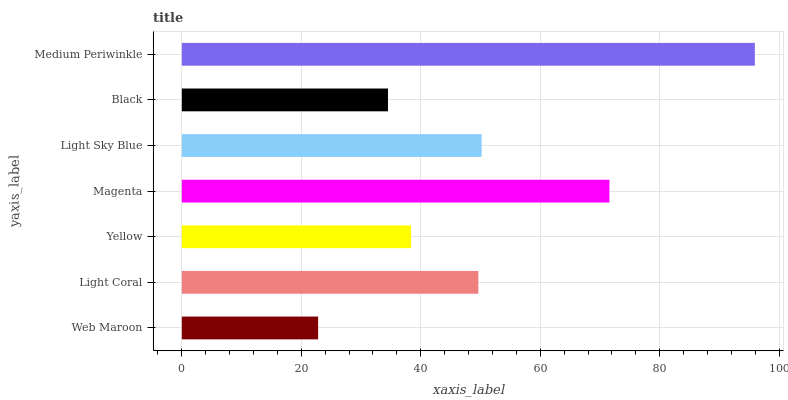Is Web Maroon the minimum?
Answer yes or no. Yes. Is Medium Periwinkle the maximum?
Answer yes or no. Yes. Is Light Coral the minimum?
Answer yes or no. No. Is Light Coral the maximum?
Answer yes or no. No. Is Light Coral greater than Web Maroon?
Answer yes or no. Yes. Is Web Maroon less than Light Coral?
Answer yes or no. Yes. Is Web Maroon greater than Light Coral?
Answer yes or no. No. Is Light Coral less than Web Maroon?
Answer yes or no. No. Is Light Coral the high median?
Answer yes or no. Yes. Is Light Coral the low median?
Answer yes or no. Yes. Is Yellow the high median?
Answer yes or no. No. Is Medium Periwinkle the low median?
Answer yes or no. No. 